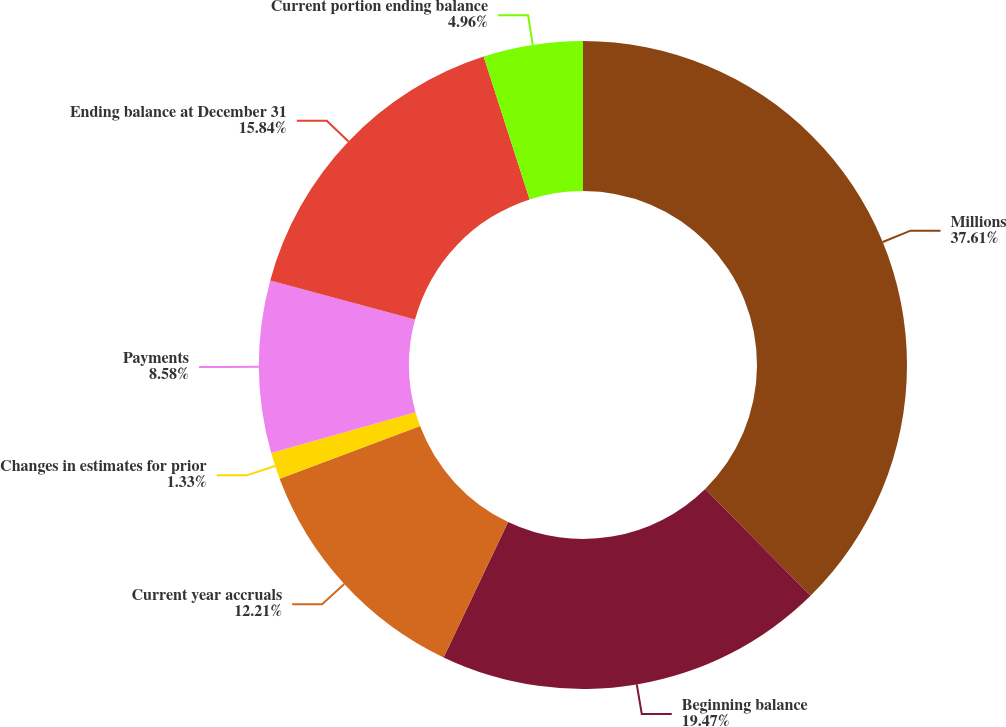Convert chart. <chart><loc_0><loc_0><loc_500><loc_500><pie_chart><fcel>Millions<fcel>Beginning balance<fcel>Current year accruals<fcel>Changes in estimates for prior<fcel>Payments<fcel>Ending balance at December 31<fcel>Current portion ending balance<nl><fcel>37.61%<fcel>19.47%<fcel>12.21%<fcel>1.33%<fcel>8.58%<fcel>15.84%<fcel>4.96%<nl></chart> 